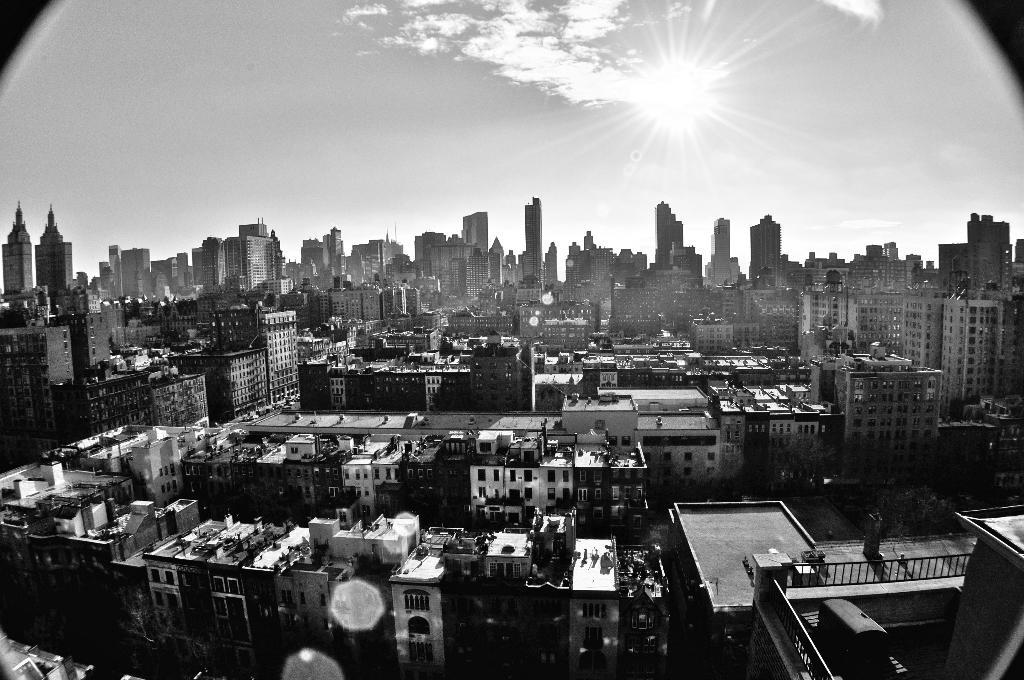What is the color scheme of the image? The image is black and white. What is the main subject of the image? The image depicts a city. What structures can be seen in the image? There are buildings in the image. What part of the natural environment is visible in the image? The sky is visible in the background of the image. Where is the library located in the image? There is no library present in the image. What type of wool can be seen in the image? There is no wool present in the image. 